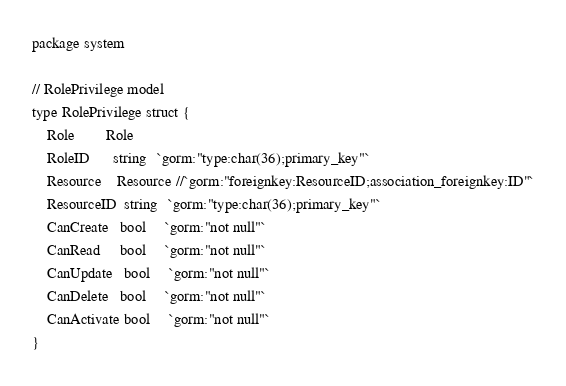Convert code to text. <code><loc_0><loc_0><loc_500><loc_500><_Go_>package system

// RolePrivilege model
type RolePrivilege struct {
	Role        Role
	RoleID      string   `gorm:"type:char(36);primary_key"`
	Resource    Resource //`gorm:"foreignkey:ResourceID;association_foreignkey:ID"`
	ResourceID  string   `gorm:"type:char(36);primary_key"`
	CanCreate   bool     `gorm:"not null"`
	CanRead     bool     `gorm:"not null"`
	CanUpdate   bool     `gorm:"not null"`
	CanDelete   bool     `gorm:"not null"`
	CanActivate bool     `gorm:"not null"`
}
</code> 